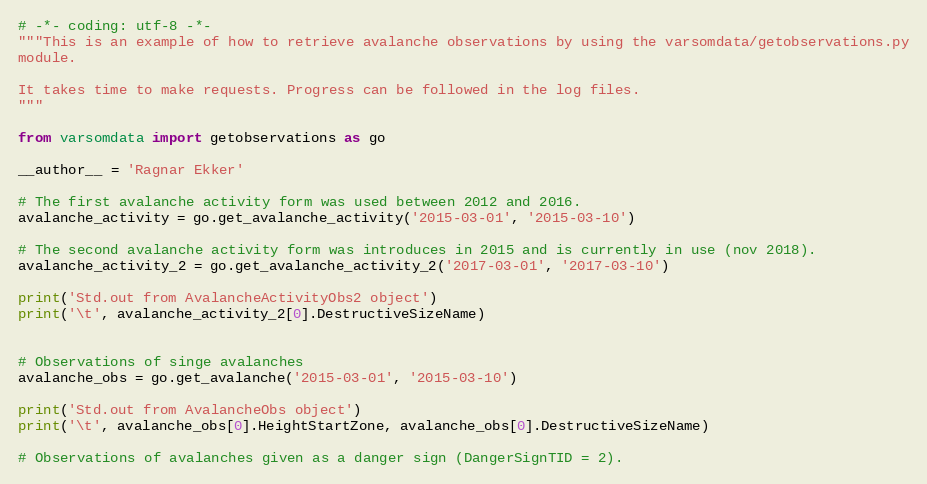<code> <loc_0><loc_0><loc_500><loc_500><_Python_># -*- coding: utf-8 -*-
"""This is an example of how to retrieve avalanche observations by using the varsomdata/getobservations.py
module.

It takes time to make requests. Progress can be followed in the log files.
"""

from varsomdata import getobservations as go

__author__ = 'Ragnar Ekker'

# The first avalanche activity form was used between 2012 and 2016.
avalanche_activity = go.get_avalanche_activity('2015-03-01', '2015-03-10')

# The second avalanche activity form was introduces in 2015 and is currently in use (nov 2018).
avalanche_activity_2 = go.get_avalanche_activity_2('2017-03-01', '2017-03-10')

print('Std.out from AvalancheActivityObs2 object')
print('\t', avalanche_activity_2[0].DestructiveSizeName)


# Observations of singe avalanches
avalanche_obs = go.get_avalanche('2015-03-01', '2015-03-10')

print('Std.out from AvalancheObs object')
print('\t', avalanche_obs[0].HeightStartZone, avalanche_obs[0].DestructiveSizeName)

# Observations of avalanches given as a danger sign (DangerSignTID = 2).</code> 